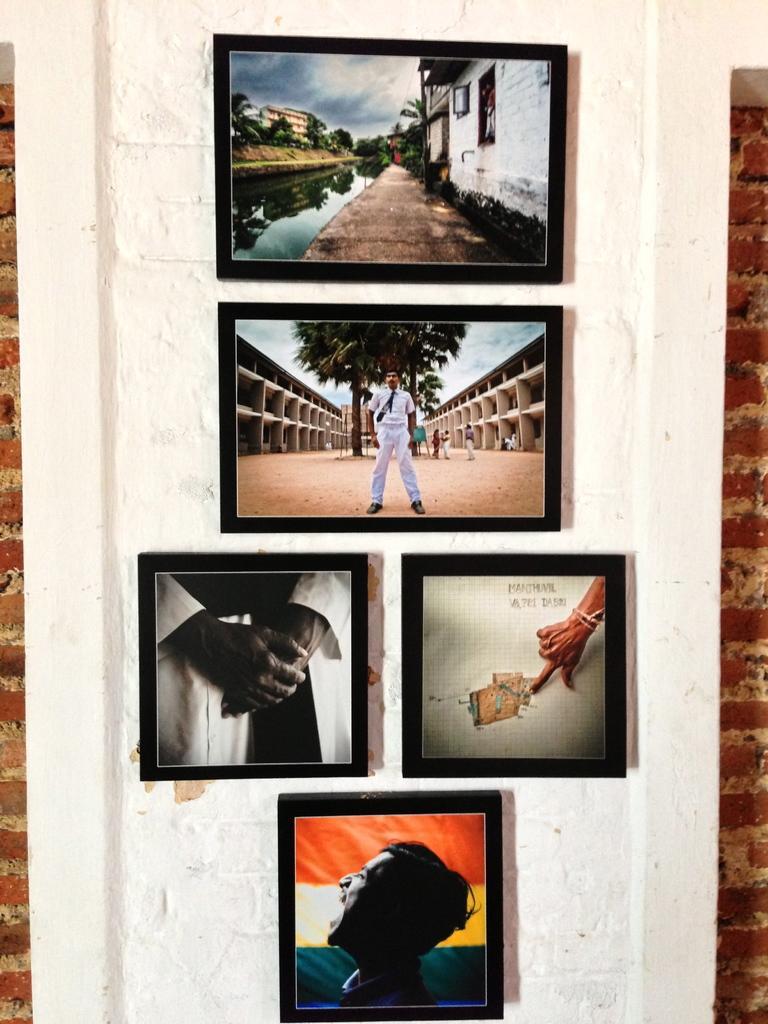In one or two sentences, can you explain what this image depicts? In this image I can see few frames attached to the white wall and brick wall. I can see buildings,trees,water,windows and few people. 